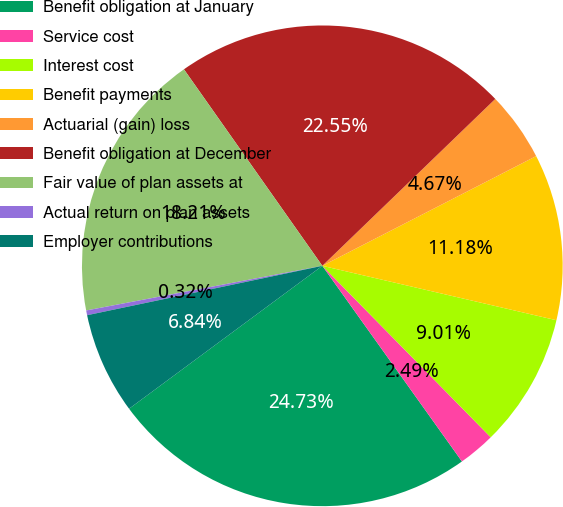Convert chart. <chart><loc_0><loc_0><loc_500><loc_500><pie_chart><fcel>Benefit obligation at January<fcel>Service cost<fcel>Interest cost<fcel>Benefit payments<fcel>Actuarial (gain) loss<fcel>Benefit obligation at December<fcel>Fair value of plan assets at<fcel>Actual return on plan assets<fcel>Employer contributions<nl><fcel>24.73%<fcel>2.49%<fcel>9.01%<fcel>11.18%<fcel>4.67%<fcel>22.55%<fcel>18.21%<fcel>0.32%<fcel>6.84%<nl></chart> 